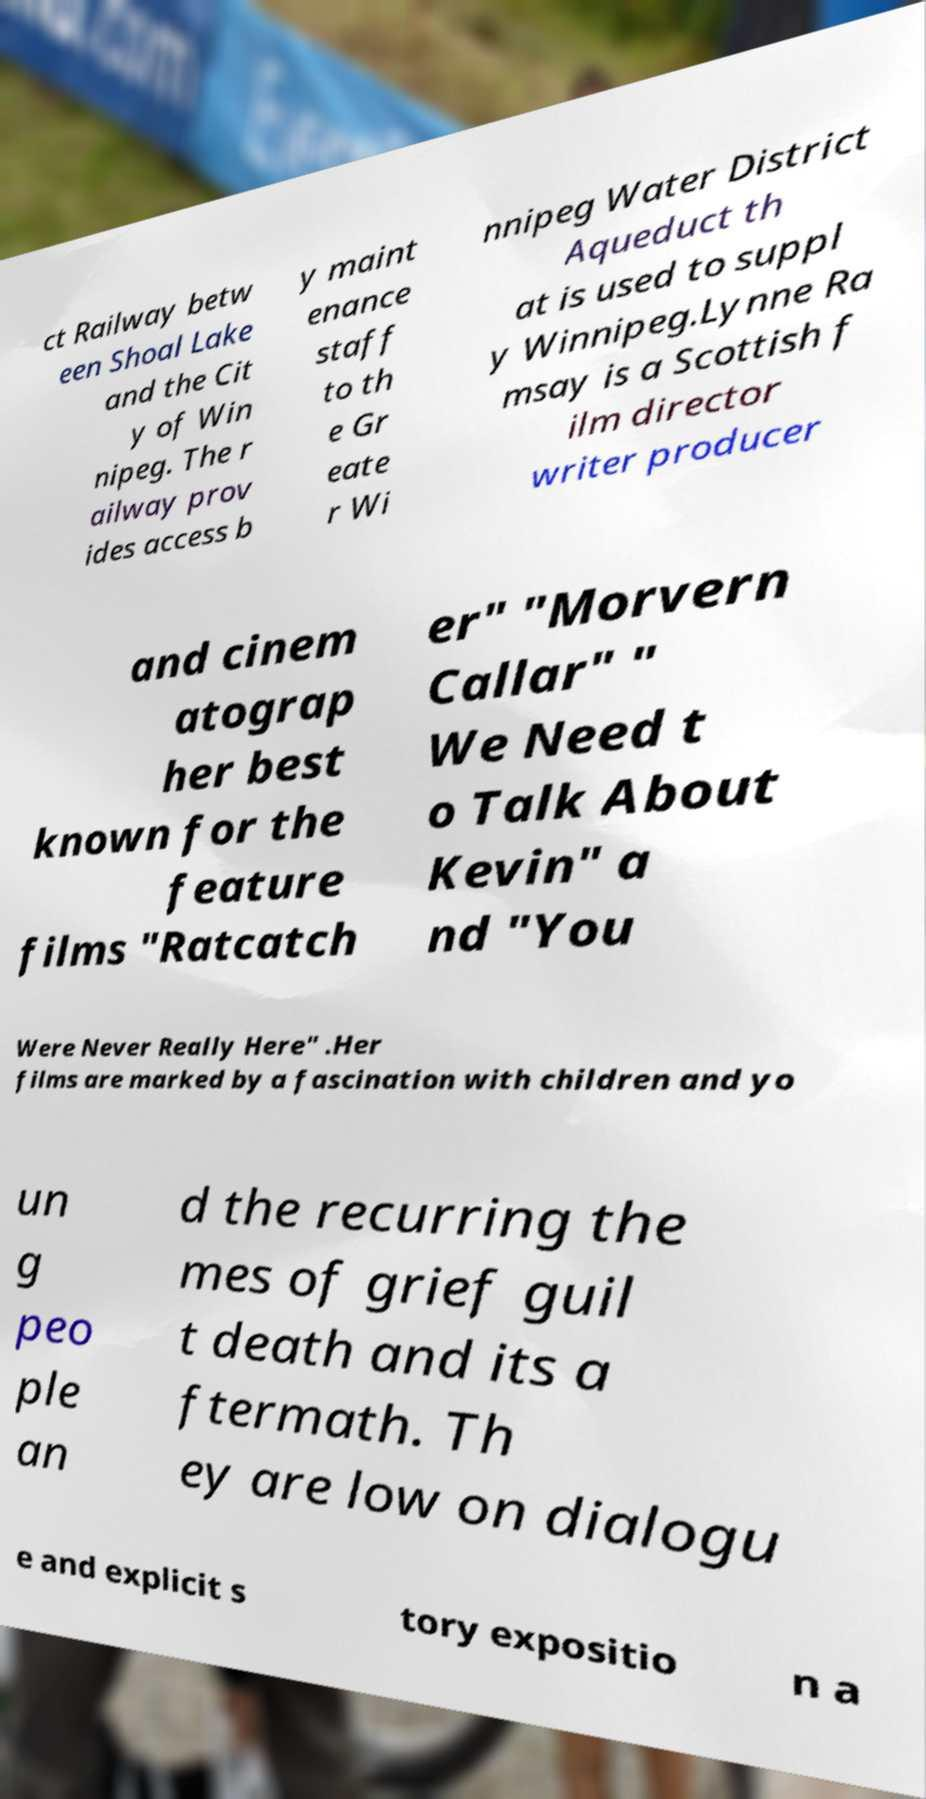Can you read and provide the text displayed in the image?This photo seems to have some interesting text. Can you extract and type it out for me? ct Railway betw een Shoal Lake and the Cit y of Win nipeg. The r ailway prov ides access b y maint enance staff to th e Gr eate r Wi nnipeg Water District Aqueduct th at is used to suppl y Winnipeg.Lynne Ra msay is a Scottish f ilm director writer producer and cinem atograp her best known for the feature films "Ratcatch er" "Morvern Callar" " We Need t o Talk About Kevin" a nd "You Were Never Really Here" .Her films are marked by a fascination with children and yo un g peo ple an d the recurring the mes of grief guil t death and its a ftermath. Th ey are low on dialogu e and explicit s tory expositio n a 